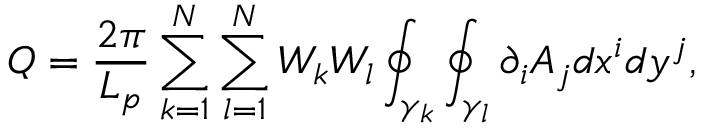Convert formula to latex. <formula><loc_0><loc_0><loc_500><loc_500>Q = \frac { 2 \pi } { L _ { p } } \sum _ { k = 1 } ^ { N } \sum _ { l = 1 } ^ { N } W _ { k } W _ { l } \oint _ { \gamma _ { k } } \oint _ { \gamma _ { l } } \partial _ { i } A _ { j } d x ^ { i } d y ^ { j } ,</formula> 